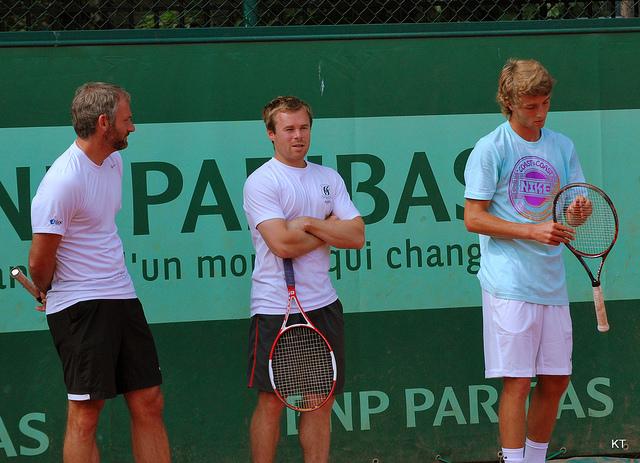How many men are in the picture?
Quick response, please. 3. Are these men playing a game?
Short answer required. Yes. What sports are they playing?
Quick response, please. Tennis. What sports equipment are they holding?
Keep it brief. Tennis rackets. 